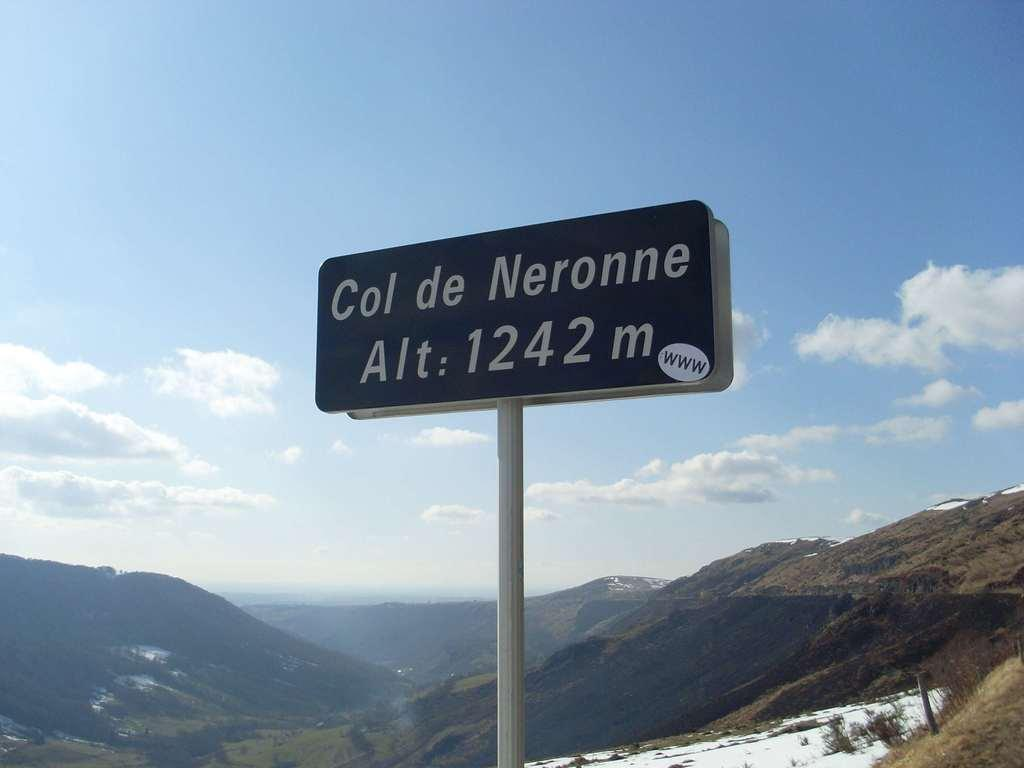<image>
Give a short and clear explanation of the subsequent image. A Alt.sign near mountains called Col de Neronne. 